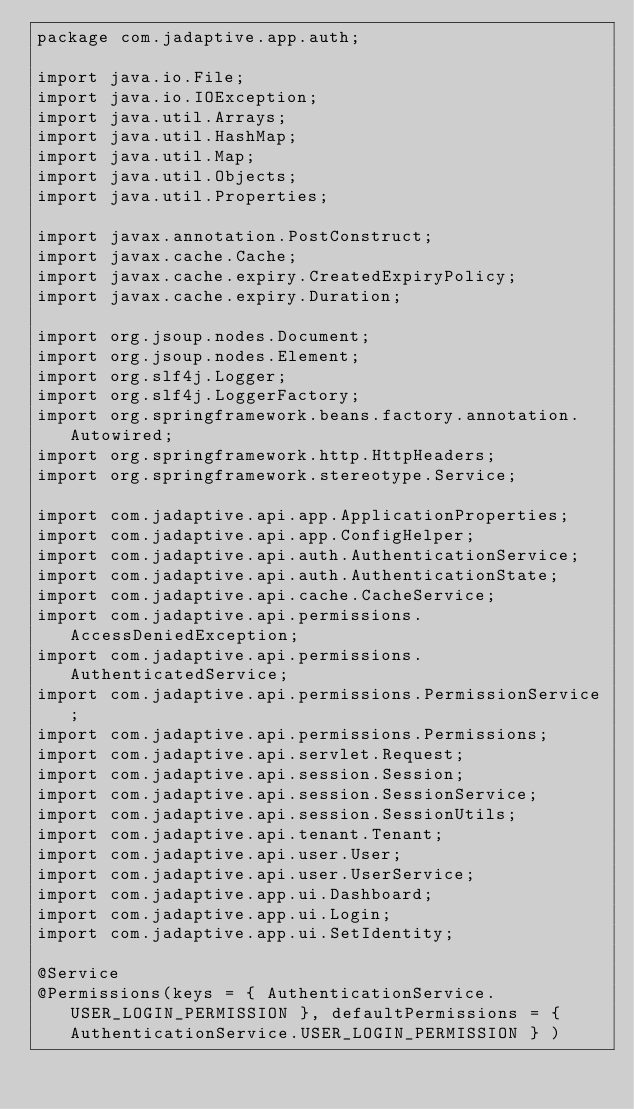Convert code to text. <code><loc_0><loc_0><loc_500><loc_500><_Java_>package com.jadaptive.app.auth;

import java.io.File;
import java.io.IOException;
import java.util.Arrays;
import java.util.HashMap;
import java.util.Map;
import java.util.Objects;
import java.util.Properties;

import javax.annotation.PostConstruct;
import javax.cache.Cache;
import javax.cache.expiry.CreatedExpiryPolicy;
import javax.cache.expiry.Duration;

import org.jsoup.nodes.Document;
import org.jsoup.nodes.Element;
import org.slf4j.Logger;
import org.slf4j.LoggerFactory;
import org.springframework.beans.factory.annotation.Autowired;
import org.springframework.http.HttpHeaders;
import org.springframework.stereotype.Service;

import com.jadaptive.api.app.ApplicationProperties;
import com.jadaptive.api.app.ConfigHelper;
import com.jadaptive.api.auth.AuthenticationService;
import com.jadaptive.api.auth.AuthenticationState;
import com.jadaptive.api.cache.CacheService;
import com.jadaptive.api.permissions.AccessDeniedException;
import com.jadaptive.api.permissions.AuthenticatedService;
import com.jadaptive.api.permissions.PermissionService;
import com.jadaptive.api.permissions.Permissions;
import com.jadaptive.api.servlet.Request;
import com.jadaptive.api.session.Session;
import com.jadaptive.api.session.SessionService;
import com.jadaptive.api.session.SessionUtils;
import com.jadaptive.api.tenant.Tenant;
import com.jadaptive.api.user.User;
import com.jadaptive.api.user.UserService;
import com.jadaptive.app.ui.Dashboard;
import com.jadaptive.app.ui.Login;
import com.jadaptive.app.ui.SetIdentity;

@Service
@Permissions(keys = { AuthenticationService.USER_LOGIN_PERMISSION }, defaultPermissions = { AuthenticationService.USER_LOGIN_PERMISSION } )</code> 